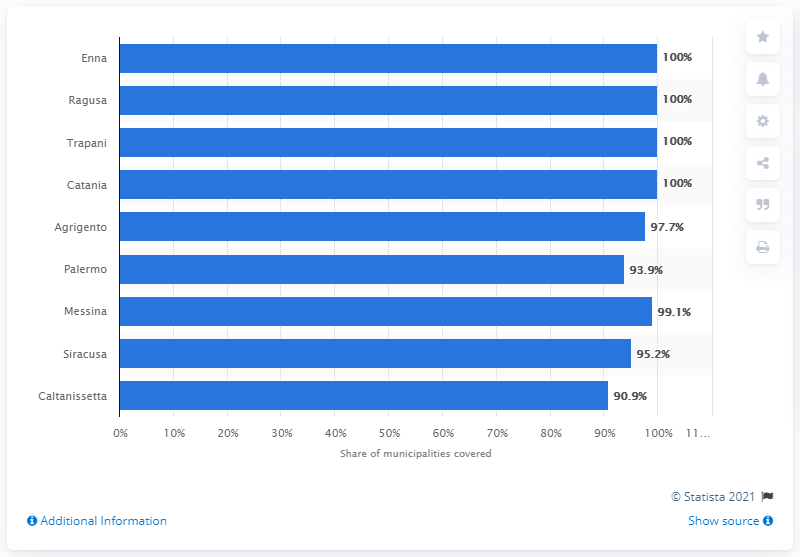Draw attention to some important aspects in this diagram. In 2018, the mobile internet penetration rate in Caltanissetta was 90.9%. According to data from 2018, Caltanissetta was the province with the lowest mobile internet penetration rate in Italy. 